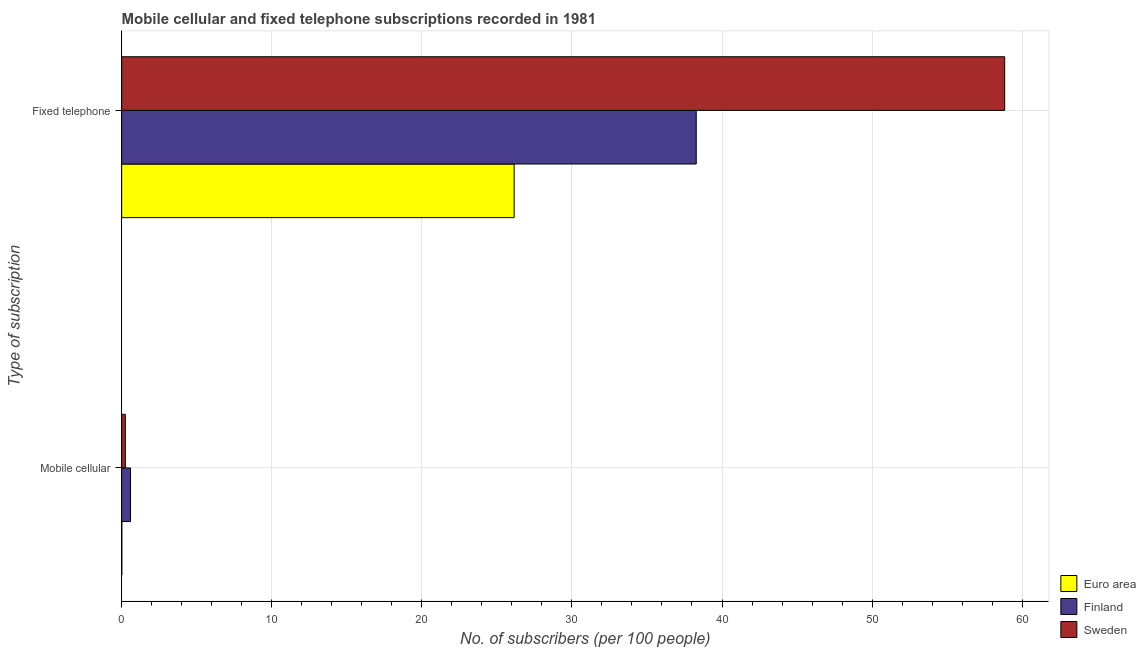How many different coloured bars are there?
Offer a very short reply. 3. How many groups of bars are there?
Give a very brief answer. 2. How many bars are there on the 1st tick from the bottom?
Give a very brief answer. 3. What is the label of the 2nd group of bars from the top?
Your answer should be very brief. Mobile cellular. What is the number of fixed telephone subscribers in Finland?
Provide a short and direct response. 38.28. Across all countries, what is the maximum number of mobile cellular subscribers?
Give a very brief answer. 0.59. Across all countries, what is the minimum number of mobile cellular subscribers?
Make the answer very short. 0.01. In which country was the number of fixed telephone subscribers minimum?
Your response must be concise. Euro area. What is the total number of mobile cellular subscribers in the graph?
Offer a terse response. 0.84. What is the difference between the number of mobile cellular subscribers in Euro area and that in Sweden?
Offer a very short reply. -0.24. What is the difference between the number of mobile cellular subscribers in Sweden and the number of fixed telephone subscribers in Euro area?
Your answer should be very brief. -25.9. What is the average number of fixed telephone subscribers per country?
Your answer should be very brief. 41.09. What is the difference between the number of fixed telephone subscribers and number of mobile cellular subscribers in Finland?
Ensure brevity in your answer.  37.7. What is the ratio of the number of fixed telephone subscribers in Euro area to that in Sweden?
Offer a very short reply. 0.44. Is the number of fixed telephone subscribers in Euro area less than that in Finland?
Provide a succinct answer. Yes. What does the 1st bar from the top in Fixed telephone represents?
Ensure brevity in your answer.  Sweden. How many bars are there?
Offer a very short reply. 6. Are all the bars in the graph horizontal?
Ensure brevity in your answer.  Yes. How many countries are there in the graph?
Provide a succinct answer. 3. Are the values on the major ticks of X-axis written in scientific E-notation?
Your answer should be very brief. No. Does the graph contain grids?
Offer a very short reply. Yes. Where does the legend appear in the graph?
Keep it short and to the point. Bottom right. How are the legend labels stacked?
Ensure brevity in your answer.  Vertical. What is the title of the graph?
Make the answer very short. Mobile cellular and fixed telephone subscriptions recorded in 1981. What is the label or title of the X-axis?
Offer a terse response. No. of subscribers (per 100 people). What is the label or title of the Y-axis?
Offer a very short reply. Type of subscription. What is the No. of subscribers (per 100 people) in Euro area in Mobile cellular?
Your response must be concise. 0.01. What is the No. of subscribers (per 100 people) in Finland in Mobile cellular?
Offer a very short reply. 0.59. What is the No. of subscribers (per 100 people) in Sweden in Mobile cellular?
Ensure brevity in your answer.  0.24. What is the No. of subscribers (per 100 people) of Euro area in Fixed telephone?
Offer a very short reply. 26.15. What is the No. of subscribers (per 100 people) of Finland in Fixed telephone?
Keep it short and to the point. 38.28. What is the No. of subscribers (per 100 people) of Sweden in Fixed telephone?
Provide a succinct answer. 58.84. Across all Type of subscription, what is the maximum No. of subscribers (per 100 people) of Euro area?
Make the answer very short. 26.15. Across all Type of subscription, what is the maximum No. of subscribers (per 100 people) in Finland?
Ensure brevity in your answer.  38.28. Across all Type of subscription, what is the maximum No. of subscribers (per 100 people) in Sweden?
Make the answer very short. 58.84. Across all Type of subscription, what is the minimum No. of subscribers (per 100 people) of Euro area?
Give a very brief answer. 0.01. Across all Type of subscription, what is the minimum No. of subscribers (per 100 people) in Finland?
Offer a terse response. 0.59. Across all Type of subscription, what is the minimum No. of subscribers (per 100 people) of Sweden?
Give a very brief answer. 0.24. What is the total No. of subscribers (per 100 people) of Euro area in the graph?
Give a very brief answer. 26.16. What is the total No. of subscribers (per 100 people) in Finland in the graph?
Provide a short and direct response. 38.87. What is the total No. of subscribers (per 100 people) in Sweden in the graph?
Your answer should be very brief. 59.08. What is the difference between the No. of subscribers (per 100 people) of Euro area in Mobile cellular and that in Fixed telephone?
Give a very brief answer. -26.14. What is the difference between the No. of subscribers (per 100 people) of Finland in Mobile cellular and that in Fixed telephone?
Your response must be concise. -37.7. What is the difference between the No. of subscribers (per 100 people) in Sweden in Mobile cellular and that in Fixed telephone?
Your answer should be very brief. -58.59. What is the difference between the No. of subscribers (per 100 people) of Euro area in Mobile cellular and the No. of subscribers (per 100 people) of Finland in Fixed telephone?
Give a very brief answer. -38.28. What is the difference between the No. of subscribers (per 100 people) in Euro area in Mobile cellular and the No. of subscribers (per 100 people) in Sweden in Fixed telephone?
Offer a very short reply. -58.83. What is the difference between the No. of subscribers (per 100 people) in Finland in Mobile cellular and the No. of subscribers (per 100 people) in Sweden in Fixed telephone?
Your answer should be compact. -58.25. What is the average No. of subscribers (per 100 people) of Euro area per Type of subscription?
Ensure brevity in your answer.  13.08. What is the average No. of subscribers (per 100 people) in Finland per Type of subscription?
Your answer should be compact. 19.44. What is the average No. of subscribers (per 100 people) of Sweden per Type of subscription?
Provide a short and direct response. 29.54. What is the difference between the No. of subscribers (per 100 people) in Euro area and No. of subscribers (per 100 people) in Finland in Mobile cellular?
Your response must be concise. -0.58. What is the difference between the No. of subscribers (per 100 people) of Euro area and No. of subscribers (per 100 people) of Sweden in Mobile cellular?
Provide a short and direct response. -0.24. What is the difference between the No. of subscribers (per 100 people) in Finland and No. of subscribers (per 100 people) in Sweden in Mobile cellular?
Your answer should be very brief. 0.34. What is the difference between the No. of subscribers (per 100 people) of Euro area and No. of subscribers (per 100 people) of Finland in Fixed telephone?
Your response must be concise. -12.14. What is the difference between the No. of subscribers (per 100 people) in Euro area and No. of subscribers (per 100 people) in Sweden in Fixed telephone?
Provide a short and direct response. -32.69. What is the difference between the No. of subscribers (per 100 people) of Finland and No. of subscribers (per 100 people) of Sweden in Fixed telephone?
Your answer should be compact. -20.55. What is the ratio of the No. of subscribers (per 100 people) in Finland in Mobile cellular to that in Fixed telephone?
Make the answer very short. 0.02. What is the ratio of the No. of subscribers (per 100 people) in Sweden in Mobile cellular to that in Fixed telephone?
Give a very brief answer. 0. What is the difference between the highest and the second highest No. of subscribers (per 100 people) of Euro area?
Ensure brevity in your answer.  26.14. What is the difference between the highest and the second highest No. of subscribers (per 100 people) of Finland?
Offer a terse response. 37.7. What is the difference between the highest and the second highest No. of subscribers (per 100 people) of Sweden?
Give a very brief answer. 58.59. What is the difference between the highest and the lowest No. of subscribers (per 100 people) of Euro area?
Ensure brevity in your answer.  26.14. What is the difference between the highest and the lowest No. of subscribers (per 100 people) in Finland?
Your answer should be compact. 37.7. What is the difference between the highest and the lowest No. of subscribers (per 100 people) in Sweden?
Give a very brief answer. 58.59. 